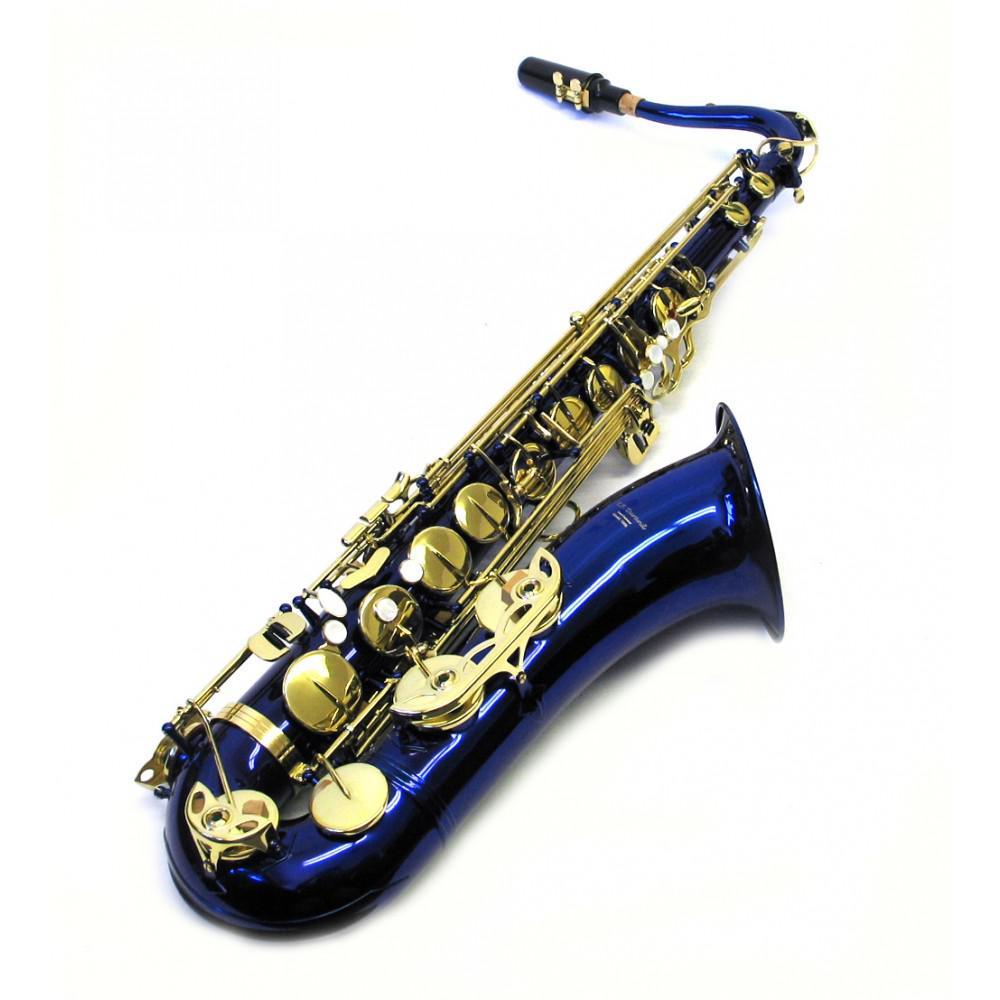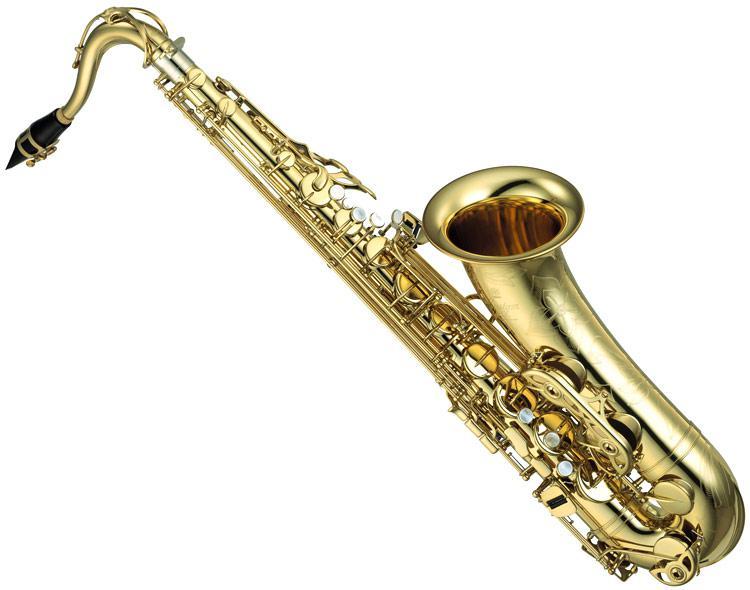The first image is the image on the left, the second image is the image on the right. Given the left and right images, does the statement "Each image has an instrument where the body is not gold, though all the buttons are." hold true? Answer yes or no. No. The first image is the image on the left, the second image is the image on the right. Analyze the images presented: Is the assertion "The saxophone on the left is bright metallic blue with gold buttons and is posed with the bell facing rightward." valid? Answer yes or no. Yes. 